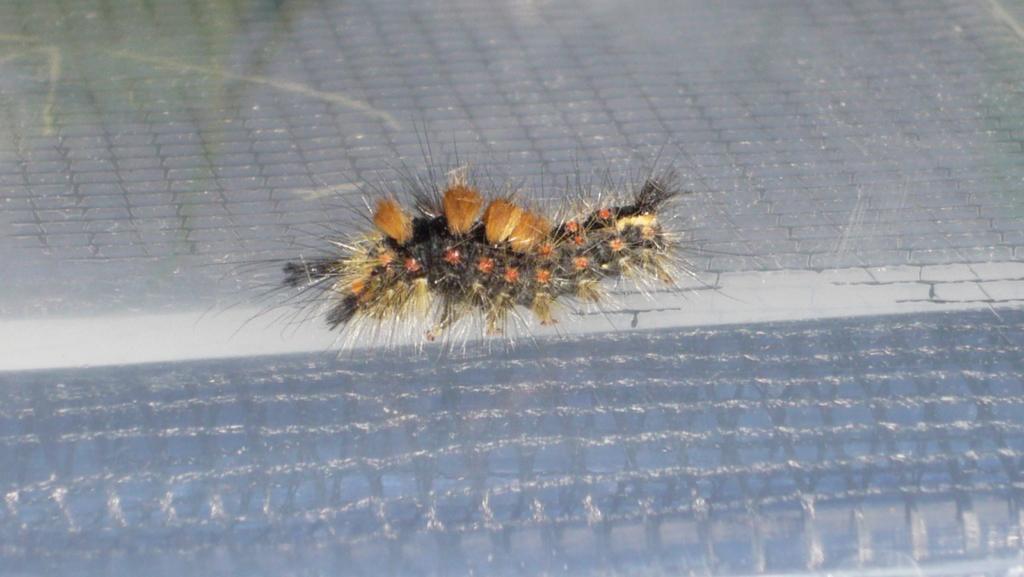Could you give a brief overview of what you see in this image? In this image I can see an insect. In the background It is looking like a floor. 